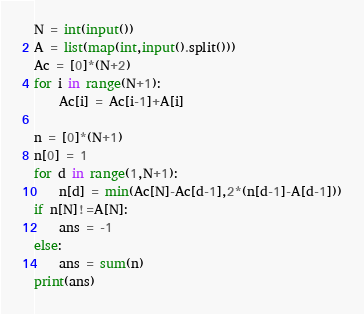Convert code to text. <code><loc_0><loc_0><loc_500><loc_500><_Python_>N = int(input())
A = list(map(int,input().split()))
Ac = [0]*(N+2)
for i in range(N+1):
    Ac[i] = Ac[i-1]+A[i]

n = [0]*(N+1)
n[0] = 1
for d in range(1,N+1):
    n[d] = min(Ac[N]-Ac[d-1],2*(n[d-1]-A[d-1]))
if n[N]!=A[N]:
    ans = -1
else:
    ans = sum(n)
print(ans)</code> 